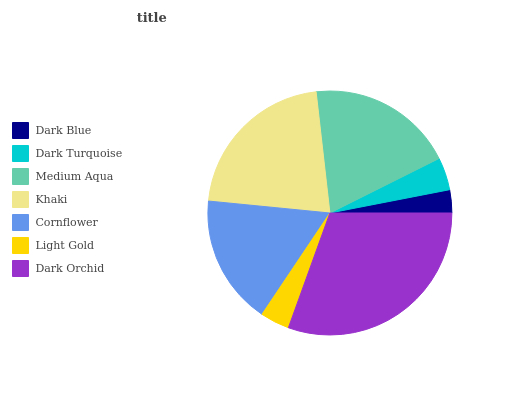Is Dark Blue the minimum?
Answer yes or no. Yes. Is Dark Orchid the maximum?
Answer yes or no. Yes. Is Dark Turquoise the minimum?
Answer yes or no. No. Is Dark Turquoise the maximum?
Answer yes or no. No. Is Dark Turquoise greater than Dark Blue?
Answer yes or no. Yes. Is Dark Blue less than Dark Turquoise?
Answer yes or no. Yes. Is Dark Blue greater than Dark Turquoise?
Answer yes or no. No. Is Dark Turquoise less than Dark Blue?
Answer yes or no. No. Is Cornflower the high median?
Answer yes or no. Yes. Is Cornflower the low median?
Answer yes or no. Yes. Is Medium Aqua the high median?
Answer yes or no. No. Is Light Gold the low median?
Answer yes or no. No. 